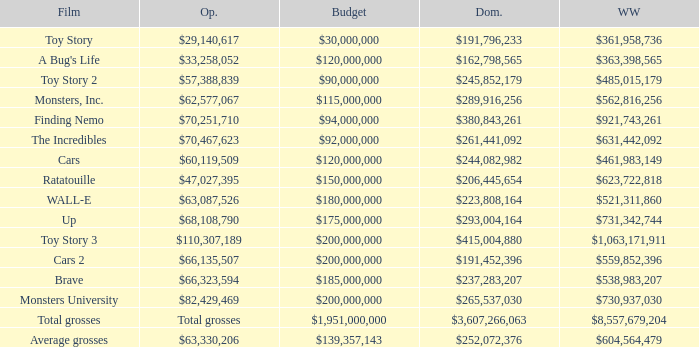WHAT IS THE BUDGET FOR THE INCREDIBLES? $92,000,000. 